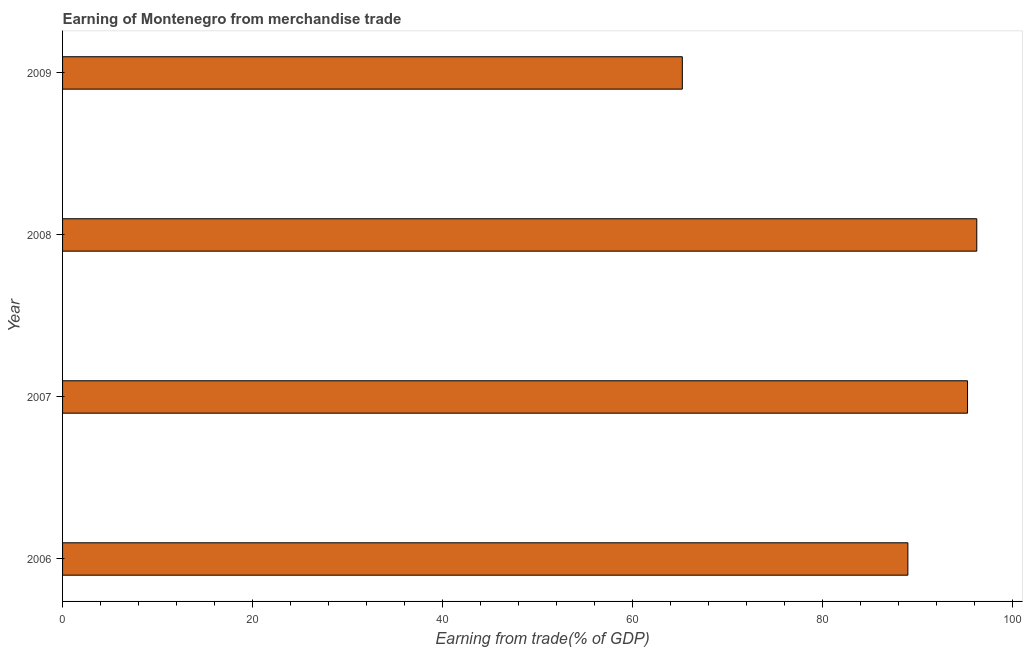Does the graph contain any zero values?
Your answer should be compact. No. Does the graph contain grids?
Give a very brief answer. No. What is the title of the graph?
Offer a terse response. Earning of Montenegro from merchandise trade. What is the label or title of the X-axis?
Your answer should be compact. Earning from trade(% of GDP). What is the earning from merchandise trade in 2008?
Keep it short and to the point. 96.2. Across all years, what is the maximum earning from merchandise trade?
Offer a terse response. 96.2. Across all years, what is the minimum earning from merchandise trade?
Your answer should be very brief. 65.21. In which year was the earning from merchandise trade maximum?
Ensure brevity in your answer.  2008. What is the sum of the earning from merchandise trade?
Your response must be concise. 345.58. What is the difference between the earning from merchandise trade in 2006 and 2007?
Ensure brevity in your answer.  -6.28. What is the average earning from merchandise trade per year?
Your response must be concise. 86.39. What is the median earning from merchandise trade?
Offer a very short reply. 92.08. In how many years, is the earning from merchandise trade greater than 24 %?
Make the answer very short. 4. What is the ratio of the earning from merchandise trade in 2006 to that in 2009?
Provide a succinct answer. 1.36. Is the sum of the earning from merchandise trade in 2006 and 2008 greater than the maximum earning from merchandise trade across all years?
Give a very brief answer. Yes. What is the difference between the highest and the lowest earning from merchandise trade?
Your answer should be very brief. 30.98. How many bars are there?
Make the answer very short. 4. How many years are there in the graph?
Provide a short and direct response. 4. Are the values on the major ticks of X-axis written in scientific E-notation?
Offer a very short reply. No. What is the Earning from trade(% of GDP) of 2006?
Keep it short and to the point. 88.94. What is the Earning from trade(% of GDP) in 2007?
Ensure brevity in your answer.  95.22. What is the Earning from trade(% of GDP) in 2008?
Your answer should be compact. 96.2. What is the Earning from trade(% of GDP) in 2009?
Your answer should be very brief. 65.21. What is the difference between the Earning from trade(% of GDP) in 2006 and 2007?
Ensure brevity in your answer.  -6.28. What is the difference between the Earning from trade(% of GDP) in 2006 and 2008?
Provide a short and direct response. -7.25. What is the difference between the Earning from trade(% of GDP) in 2006 and 2009?
Offer a terse response. 23.73. What is the difference between the Earning from trade(% of GDP) in 2007 and 2008?
Give a very brief answer. -0.97. What is the difference between the Earning from trade(% of GDP) in 2007 and 2009?
Your answer should be very brief. 30.01. What is the difference between the Earning from trade(% of GDP) in 2008 and 2009?
Ensure brevity in your answer.  30.98. What is the ratio of the Earning from trade(% of GDP) in 2006 to that in 2007?
Your response must be concise. 0.93. What is the ratio of the Earning from trade(% of GDP) in 2006 to that in 2008?
Your answer should be very brief. 0.93. What is the ratio of the Earning from trade(% of GDP) in 2006 to that in 2009?
Keep it short and to the point. 1.36. What is the ratio of the Earning from trade(% of GDP) in 2007 to that in 2008?
Offer a terse response. 0.99. What is the ratio of the Earning from trade(% of GDP) in 2007 to that in 2009?
Provide a short and direct response. 1.46. What is the ratio of the Earning from trade(% of GDP) in 2008 to that in 2009?
Make the answer very short. 1.48. 